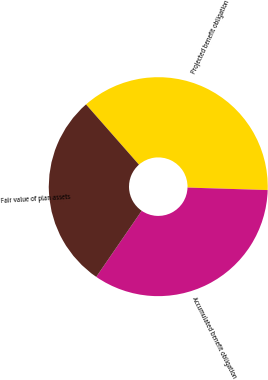Convert chart to OTSL. <chart><loc_0><loc_0><loc_500><loc_500><pie_chart><fcel>Projected benefit obligation<fcel>Accumulated benefit obligation<fcel>Fair value of plan assets<nl><fcel>36.97%<fcel>34.09%<fcel>28.94%<nl></chart> 